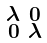Convert formula to latex. <formula><loc_0><loc_0><loc_500><loc_500>\begin{smallmatrix} \lambda & 0 \\ 0 & \lambda \end{smallmatrix}</formula> 